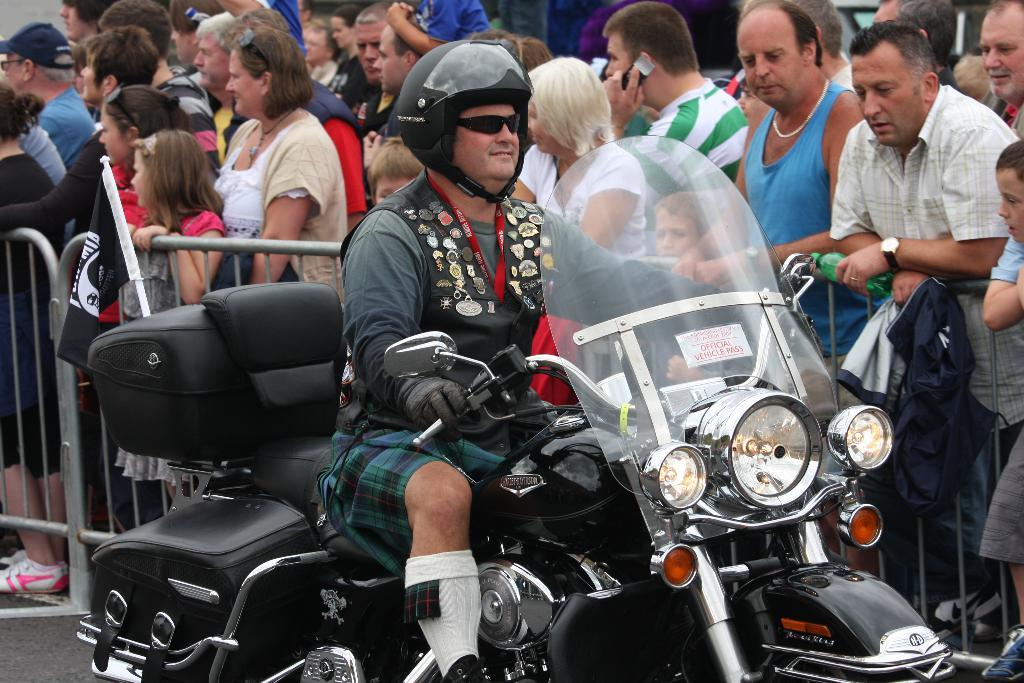What is the man in the image doing? The man is riding a motorcycle in the image. What else can be seen in the image besides the man on the motorcycle? There are people standing in the image, as well as a metal fence. Is there any symbol or emblem on the motorcycle? Yes, there is a flag on the motorcycle. Where can the receipt for the motorcycle be found in the image? There is no receipt present in the image. What type of fiction is being read by the people standing in the image? There is no indication of any fiction being read in the image. 